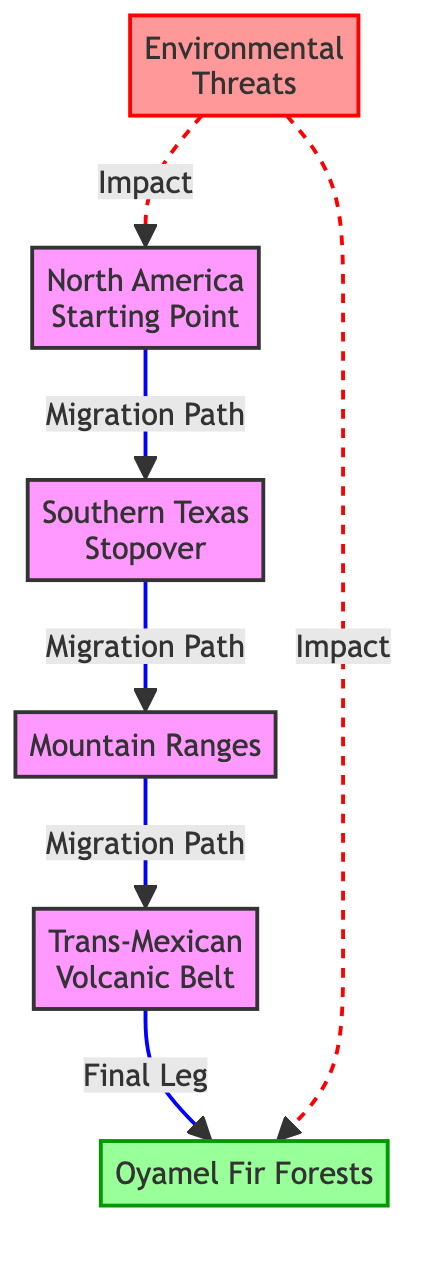What is the starting point of the monarch butterfly migration? The diagram shows "North America" as the starting point, indicating where the migration begins.
Answer: North America What is the final destination of the migration? In the diagram, "Oyamel Fir Forests" is labeled as the final destination where the butterflies complete their journey.
Answer: Oyamel Fir Forests How many main stopping points are listed in the diagram? The diagram features three key stopping points: "Southern Texas," "Mountain Ranges," and "Trans-Mexican Volcanic Belt," leading to the final destination.
Answer: 3 What type of environmental factors are indicated in the diagram? The diagram points out "Environmental Threats," which are illustrated as factors impacting the starting point and final destination in the migration path.
Answer: Environmental Threats Which stopover occurs after Southern Texas in the migration path? The diagram clearly shows that following the "Southern Texas" stopover, the next point is "Mountain Ranges," indicating the sequence in the migration.
Answer: Mountain Ranges What is the relationship between "Environmental Threats" and the starting point? The diagram indicates that "Environmental Threats" have an impacting relationship with "North America," signifying that these threats influence the migration process from the start.
Answer: Impact What is represented as the last leg of migration in the diagram? According to the diagram, the "Trans-Mexican Volcanic Belt" is designated as the last leg before reaching the final destination, showing its position in the migration route.
Answer: Trans-Mexican Volcanic Belt What type of link is used to connect the environmental threats to the starting point and final destination? The diagram illustrates that the links connecting "Environmental Threats" to both the starting point ("North America") and the final destination ("Oyamel Fir Forests") are dashed, indicating a non-direct or indirect relationship.
Answer: Dashed link How is the "Oyamel Fir Forests" visually distinguished in the diagram? The diagram visually distinguishes the "Oyamel Fir Forests" by assigning it a specific class with a different color (green), signifying its importance as the destination in the migration path.
Answer: Green class 